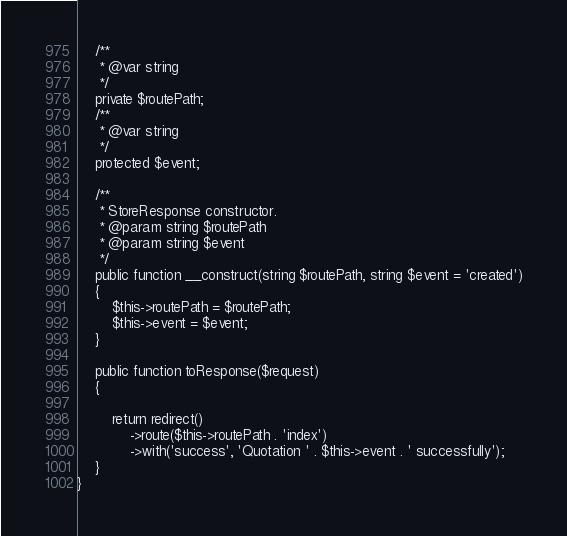<code> <loc_0><loc_0><loc_500><loc_500><_PHP_>    /**
     * @var string
     */
    private $routePath;
    /**
     * @var string
     */
    protected $event;

    /**
     * StoreResponse constructor.
     * @param string $routePath
     * @param string $event
     */
    public function __construct(string $routePath, string $event = 'created')
    {
        $this->routePath = $routePath;
        $this->event = $event;
    }

    public function toResponse($request)
    {

        return redirect()
            ->route($this->routePath . 'index')
            ->with('success', 'Quotation ' . $this->event . ' successfully');
    }
}
</code> 